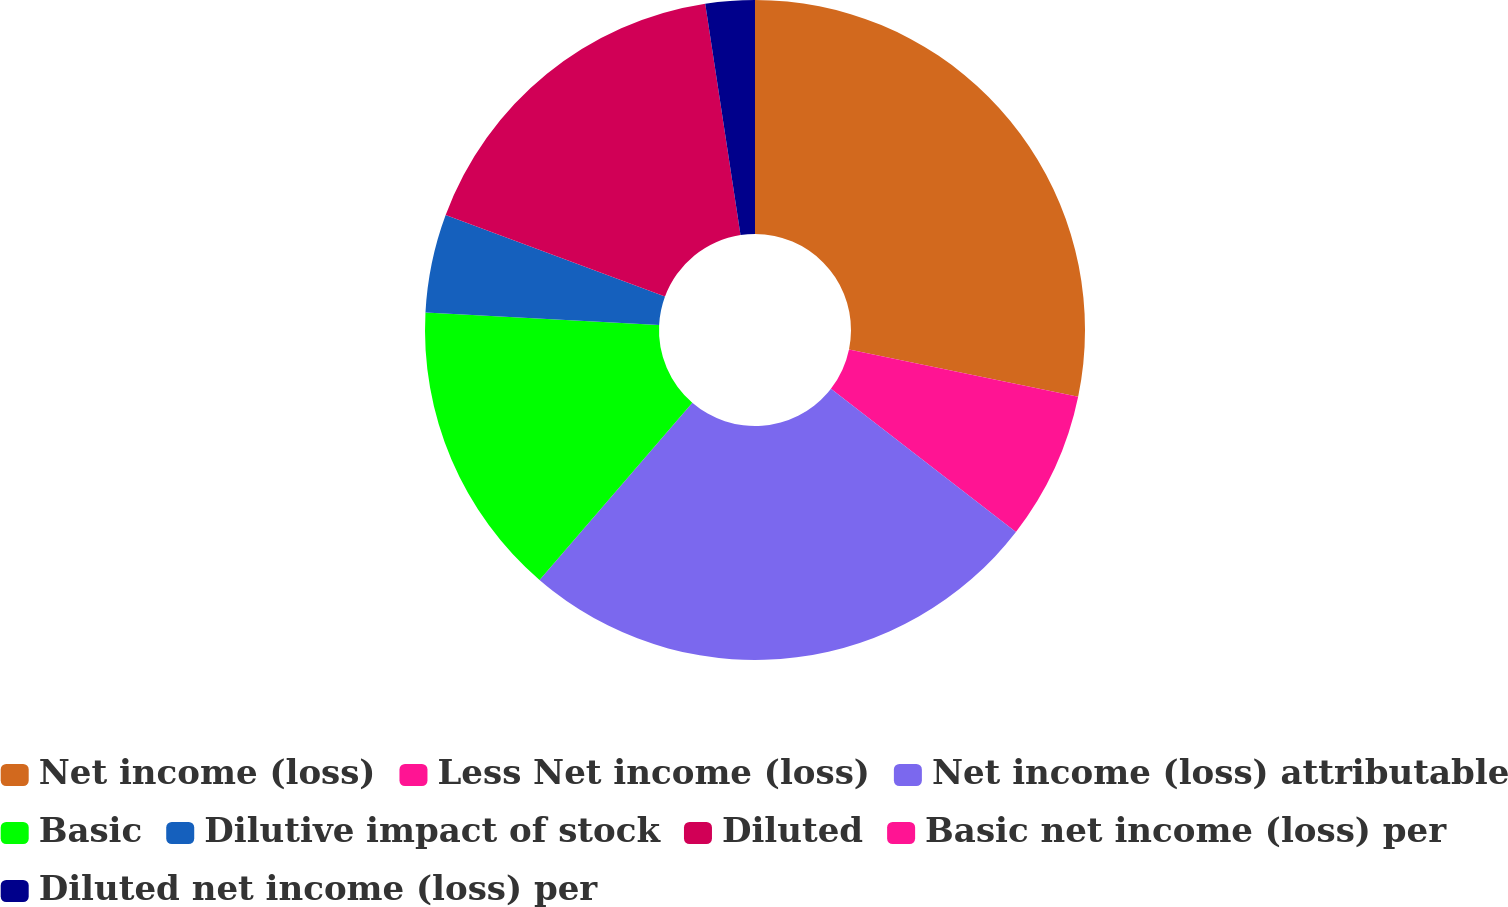Convert chart to OTSL. <chart><loc_0><loc_0><loc_500><loc_500><pie_chart><fcel>Net income (loss)<fcel>Less Net income (loss)<fcel>Net income (loss) attributable<fcel>Basic<fcel>Dilutive impact of stock<fcel>Diluted<fcel>Basic net income (loss) per<fcel>Diluted net income (loss) per<nl><fcel>28.25%<fcel>7.24%<fcel>25.84%<fcel>14.52%<fcel>4.82%<fcel>16.93%<fcel>0.0%<fcel>2.41%<nl></chart> 